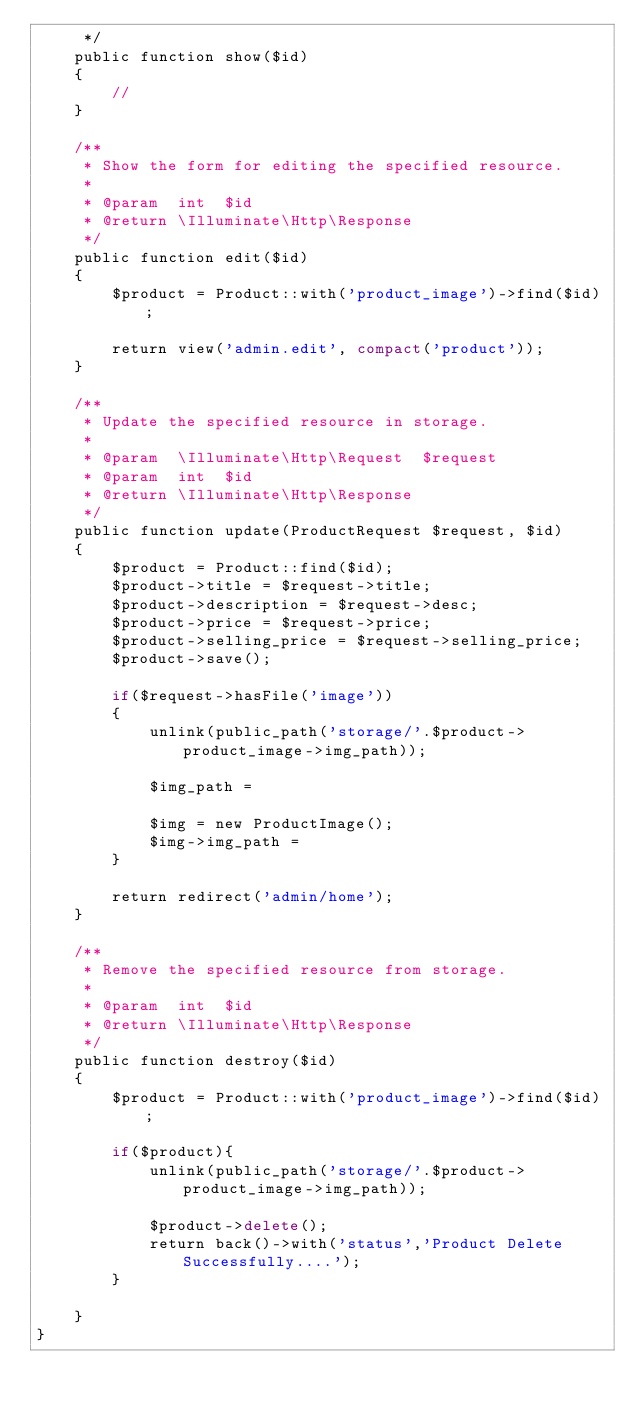Convert code to text. <code><loc_0><loc_0><loc_500><loc_500><_PHP_>     */
    public function show($id)
    {
        //
    }

    /**
     * Show the form for editing the specified resource.
     *
     * @param  int  $id
     * @return \Illuminate\Http\Response
     */
    public function edit($id)
    {
        $product = Product::with('product_image')->find($id);

        return view('admin.edit', compact('product'));
    }

    /**
     * Update the specified resource in storage.
     *
     * @param  \Illuminate\Http\Request  $request
     * @param  int  $id
     * @return \Illuminate\Http\Response
     */
    public function update(ProductRequest $request, $id)
    {
        $product = Product::find($id);
        $product->title = $request->title;
        $product->description = $request->desc;
        $product->price = $request->price;
        $product->selling_price = $request->selling_price;
        $product->save();
        
        if($request->hasFile('image'))
        {
            unlink(public_path('storage/'.$product->product_image->img_path));

            $img_path = 

            $img = new ProductImage();
            $img->img_path =   
        }

        return redirect('admin/home');
    }

    /**
     * Remove the specified resource from storage.
     *
     * @param  int  $id
     * @return \Illuminate\Http\Response
     */
    public function destroy($id)
    {
        $product = Product::with('product_image')->find($id);

        if($product){
            unlink(public_path('storage/'.$product->product_image->img_path));

            $product->delete();
            return back()->with('status','Product Delete Successfully....');
        }

    }
}
</code> 